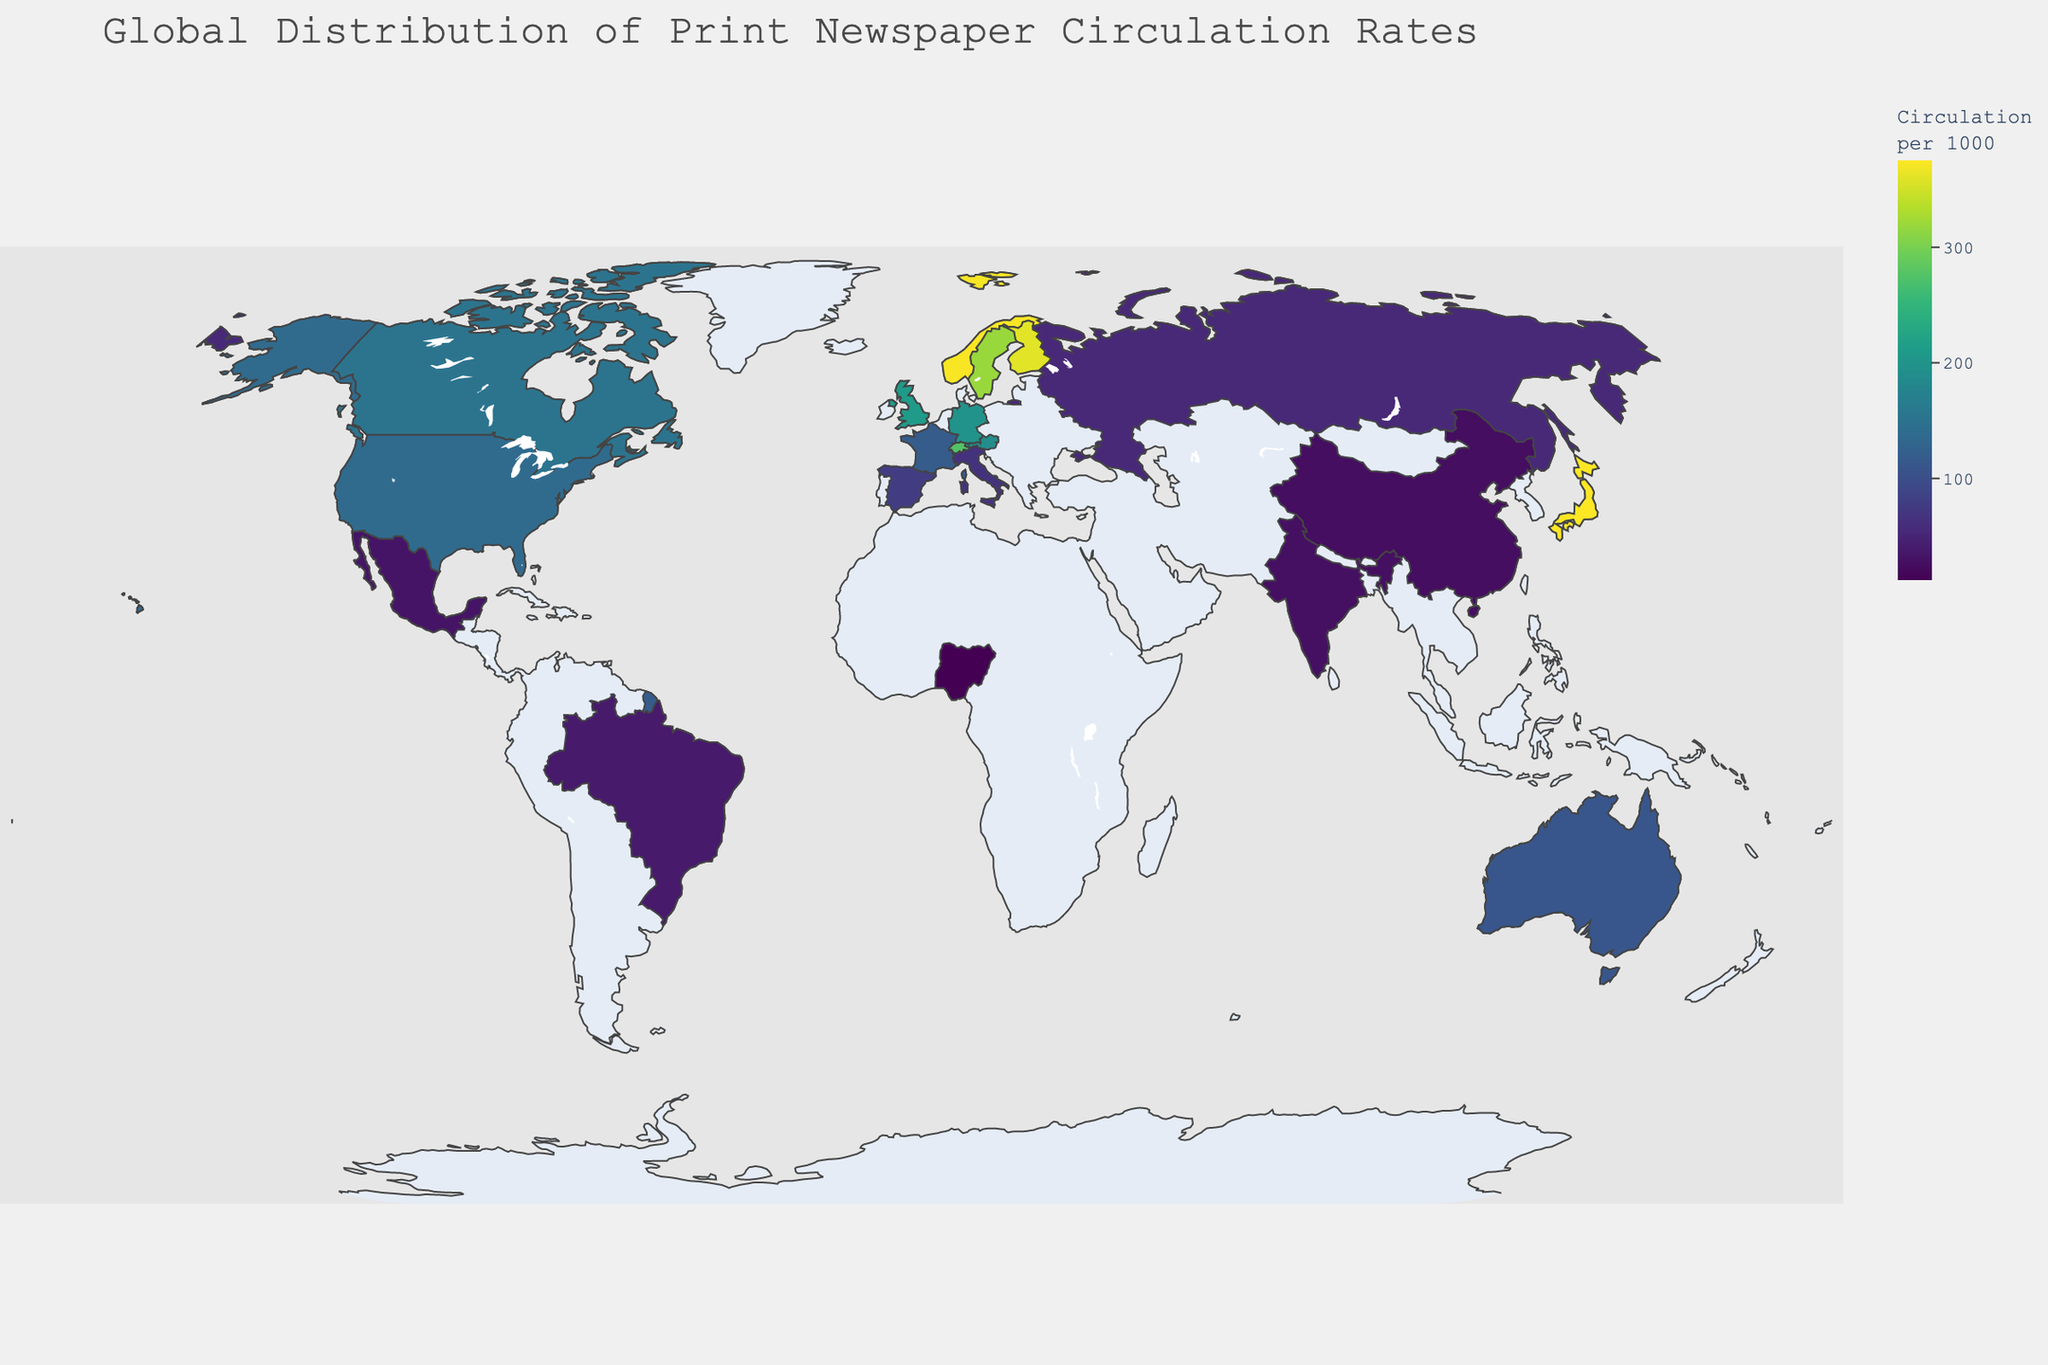What's the title of the plot? The title is displayed at the top of the figure and it summarizes the data visualized.
Answer: Global Distribution of Print Newspaper Circulation Rates How is the circulation rate measured in this plot? The circulation rate is measured per 1000 population, as indicated in the title and color bar label.
Answer: Per 1000 population Which country has the highest newspaper circulation rate? Looking at the countries shaded with the darkest color, Japan stands out as having the highest circulation rate.
Answer: Japan Which countries have a circulation rate above 300 per 1000 population? The countries shaded dark in the top range (>300) include Japan, Norway, and Finland.
Answer: Japan, Norway, Finland What is the circulation rate for the United States? Hovering over the United States on the map or checking the legend shows the specific rate.
Answer: 137 How does the newspaper circulation rate of Brazil compare to that of China? Brazil has a slightly higher circulation rate in comparison to China, which can be observed by comparing their respective colors and data values.
Answer: Brazil has higher circulation than China What is the average newspaper circulation rate among the top 3 countries? The circulation rates for Japan, Norway, and Finland are 375, 372, and 360 respectively. Average is calculated as (375 + 372 + 360) / 3.
Answer: 369 Which country has the lowest newspaper circulation rate? Using the lightest color on the map, Nigeria is the country with the lowest rate.
Answer: Nigeria How many countries have a circulation rate below 50 per 1000 population? The countries shaded in the lightest colors (with rates <50) include Nigeria, China, India, Mexico, and Brazil.
Answer: 5 countries Is there a notable difference in newspaper circulation rates between European and Asian countries? European countries generally have higher circulation rates than Asian countries, as seen by the darker shades in Europe compared to lighter shades in Asia.
Answer: Yes, European countries generally have higher rates than Asian countries 